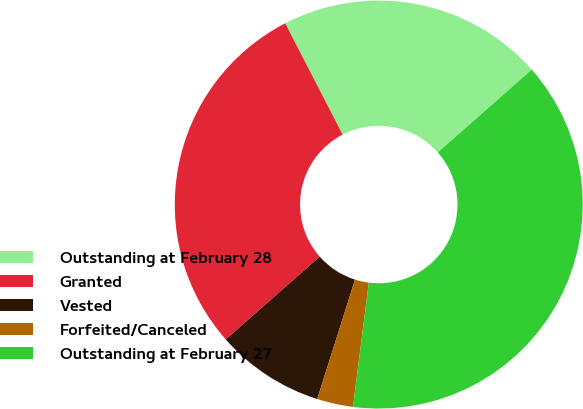Convert chart. <chart><loc_0><loc_0><loc_500><loc_500><pie_chart><fcel>Outstanding at February 28<fcel>Granted<fcel>Vested<fcel>Forfeited/Canceled<fcel>Outstanding at February 27<nl><fcel>21.08%<fcel>28.92%<fcel>8.62%<fcel>2.86%<fcel>38.52%<nl></chart> 